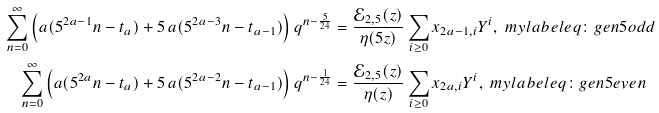Convert formula to latex. <formula><loc_0><loc_0><loc_500><loc_500>\sum _ { n = 0 } ^ { \infty } \left ( a ( 5 ^ { 2 a - 1 } n - t _ { a } ) + 5 \, a ( 5 ^ { 2 a - 3 } n - t _ { a - 1 } ) \right ) q ^ { n - \frac { 5 } { 2 4 } } & = \frac { \mathcal { E } _ { 2 , 5 } ( z ) } { \eta ( 5 z ) } \sum _ { i \geq 0 } x _ { 2 a - 1 , i } Y ^ { i } , \ m y l a b e l { e q \colon g e n 5 o d d } \\ \sum _ { n = 0 } ^ { \infty } \left ( a ( 5 ^ { 2 a } n - t _ { a } ) + 5 \, a ( 5 ^ { 2 a - 2 } n - t _ { a - 1 } ) \right ) q ^ { n - \frac { 1 } { 2 4 } } & = \frac { \mathcal { E } _ { 2 , 5 } ( z ) } { \eta ( z ) } \sum _ { i \geq 0 } x _ { 2 a , i } Y ^ { i } , \ m y l a b e l { e q \colon g e n 5 e v e n }</formula> 